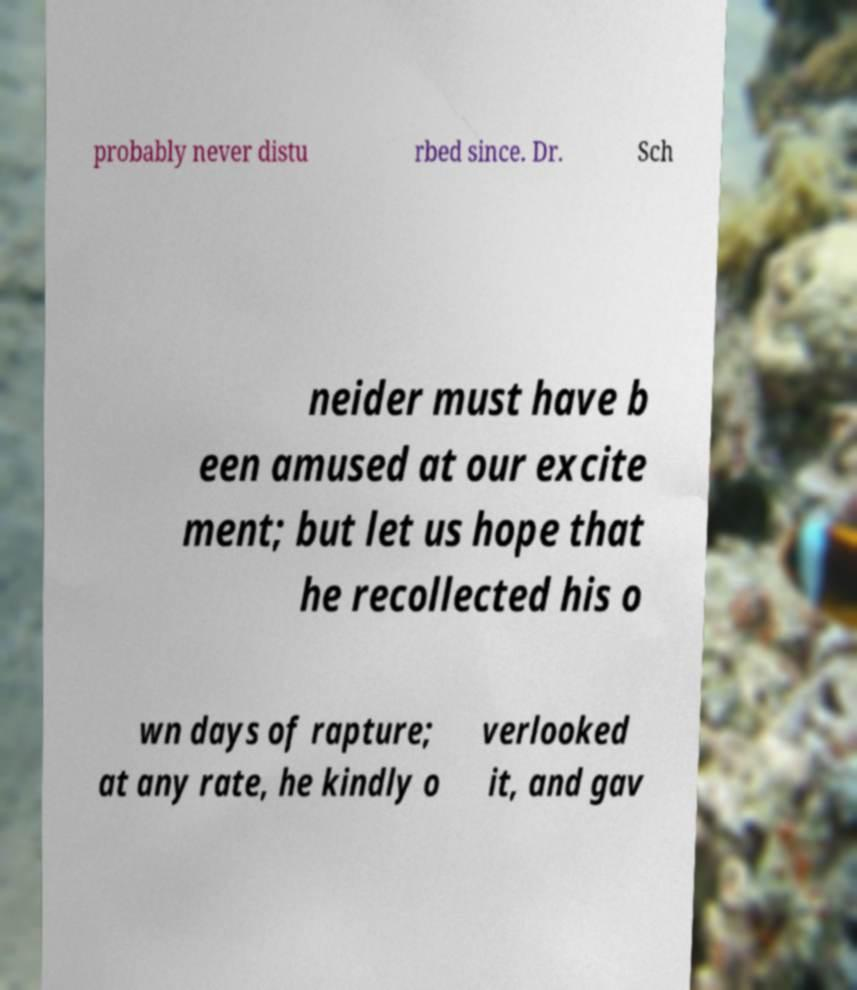Please identify and transcribe the text found in this image. probably never distu rbed since. Dr. Sch neider must have b een amused at our excite ment; but let us hope that he recollected his o wn days of rapture; at any rate, he kindly o verlooked it, and gav 